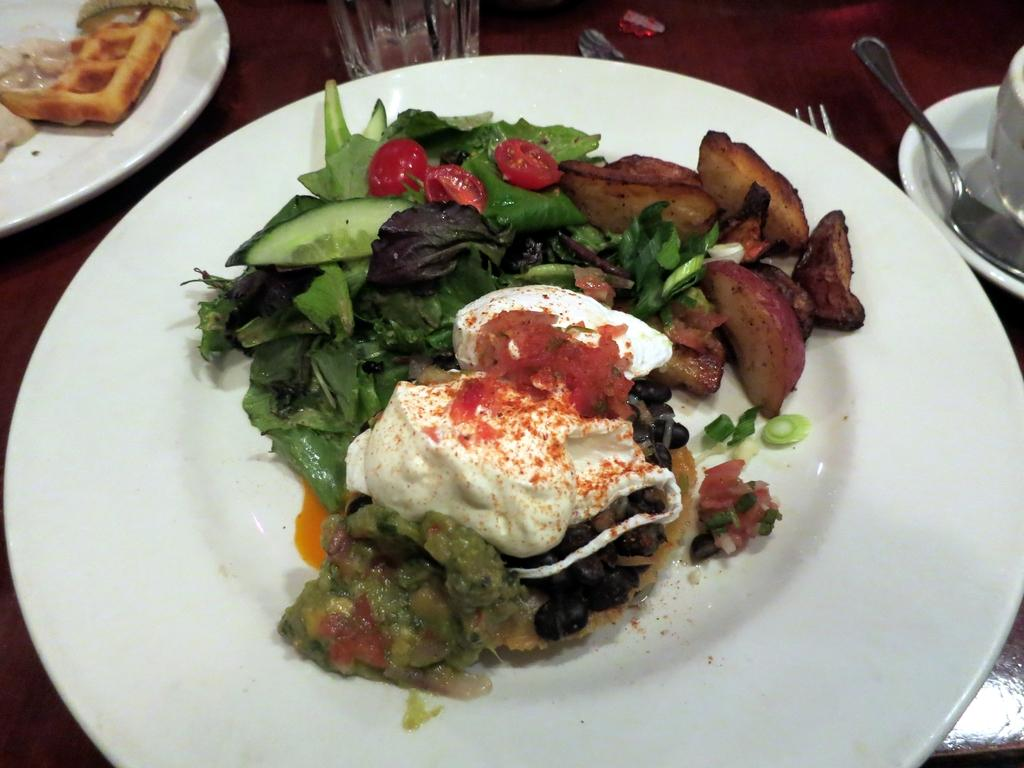What types of food items can be seen in the image? The food items in the image are in white, red, and green colors. What is the color of the plate in the image? The plate in the image is white in color. What other tableware can be seen in the image? There is a glass, a fork, and a spoon in the image. Can you see the smile on the food items in the image? There are no faces or expressions on the food items in the image, so there is no smile to be seen. 